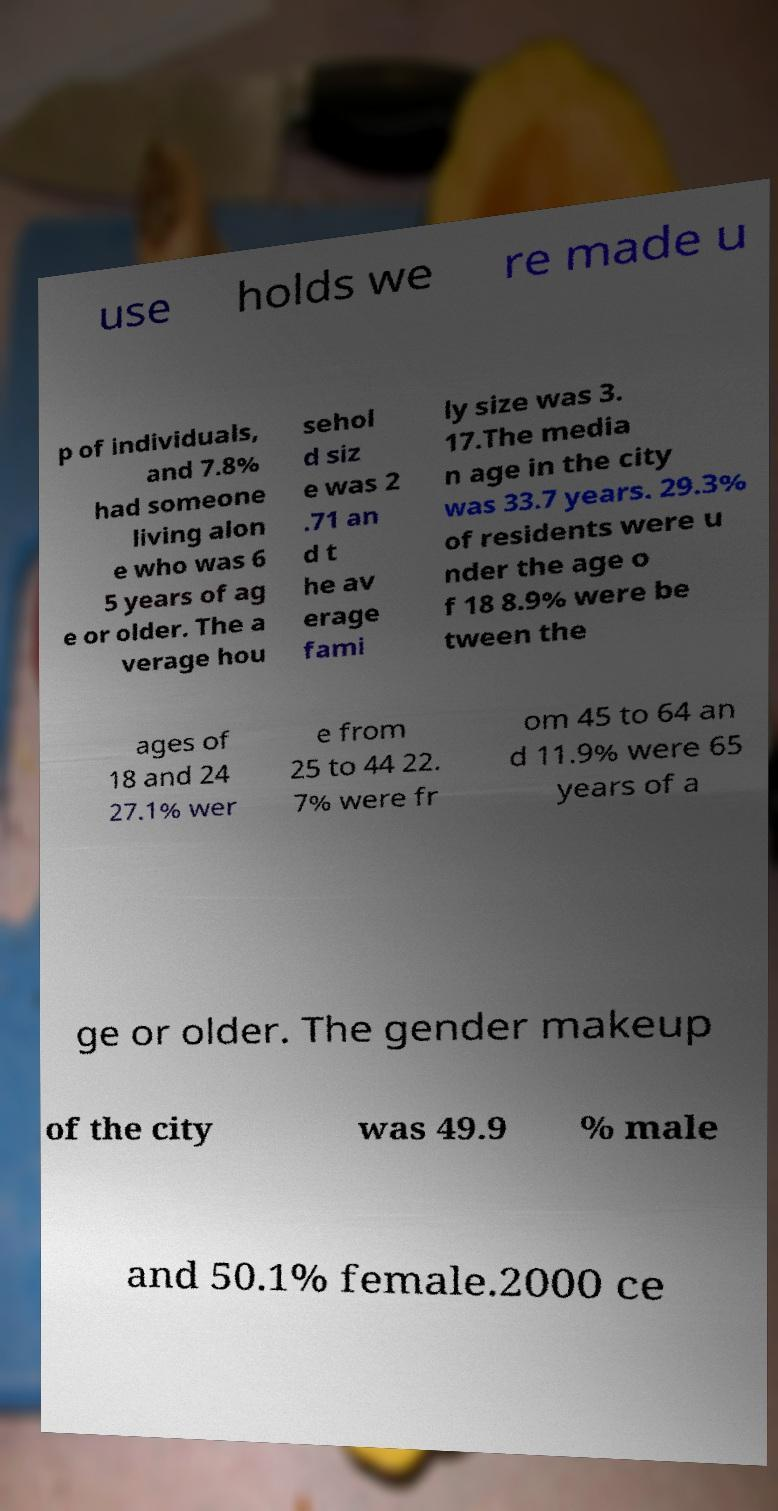Could you assist in decoding the text presented in this image and type it out clearly? use holds we re made u p of individuals, and 7.8% had someone living alon e who was 6 5 years of ag e or older. The a verage hou sehol d siz e was 2 .71 an d t he av erage fami ly size was 3. 17.The media n age in the city was 33.7 years. 29.3% of residents were u nder the age o f 18 8.9% were be tween the ages of 18 and 24 27.1% wer e from 25 to 44 22. 7% were fr om 45 to 64 an d 11.9% were 65 years of a ge or older. The gender makeup of the city was 49.9 % male and 50.1% female.2000 ce 